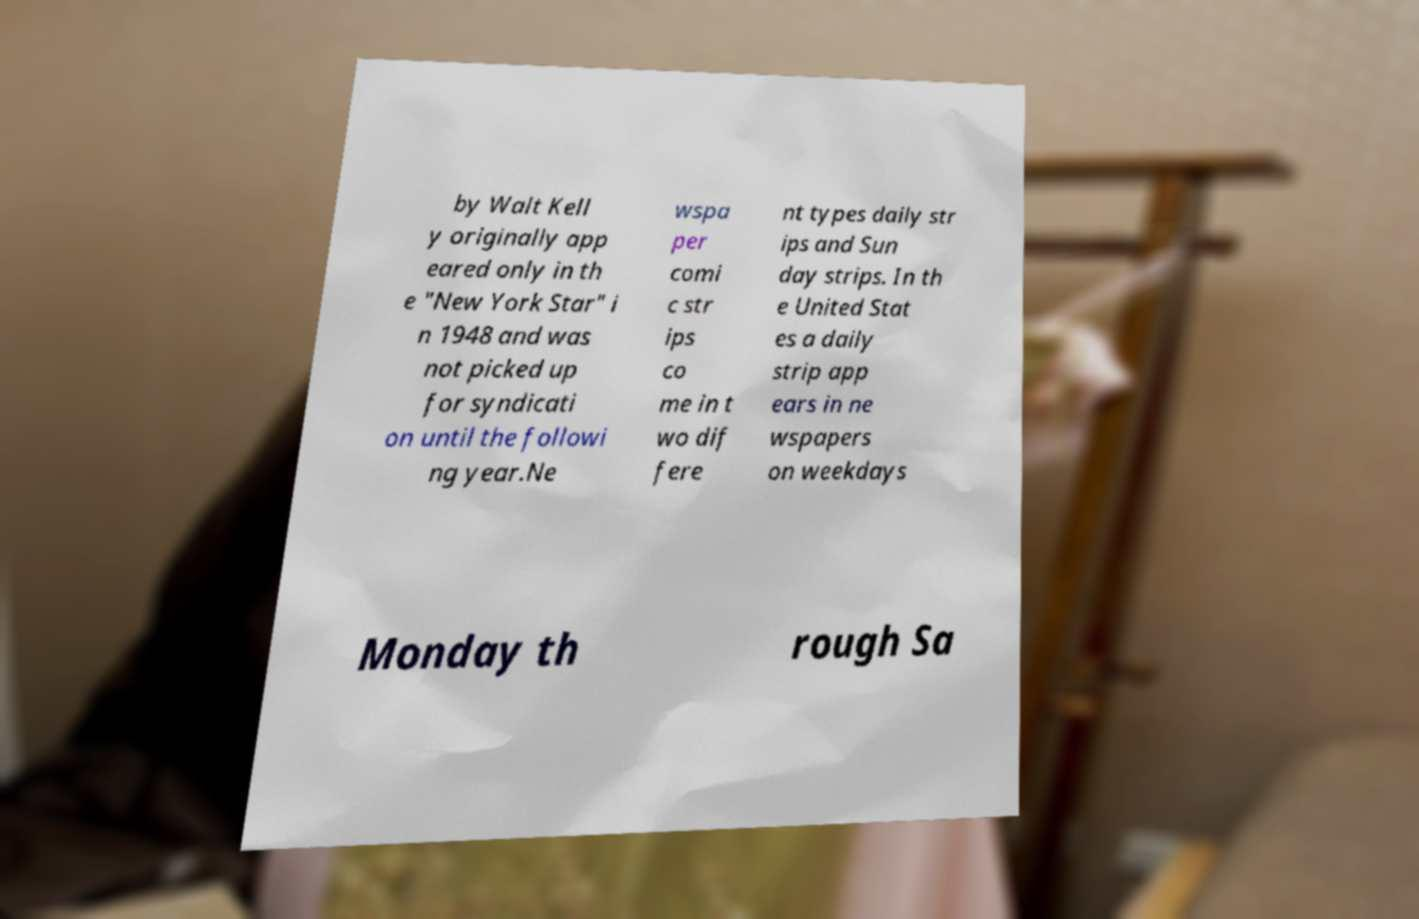Could you assist in decoding the text presented in this image and type it out clearly? by Walt Kell y originally app eared only in th e "New York Star" i n 1948 and was not picked up for syndicati on until the followi ng year.Ne wspa per comi c str ips co me in t wo dif fere nt types daily str ips and Sun day strips. In th e United Stat es a daily strip app ears in ne wspapers on weekdays Monday th rough Sa 